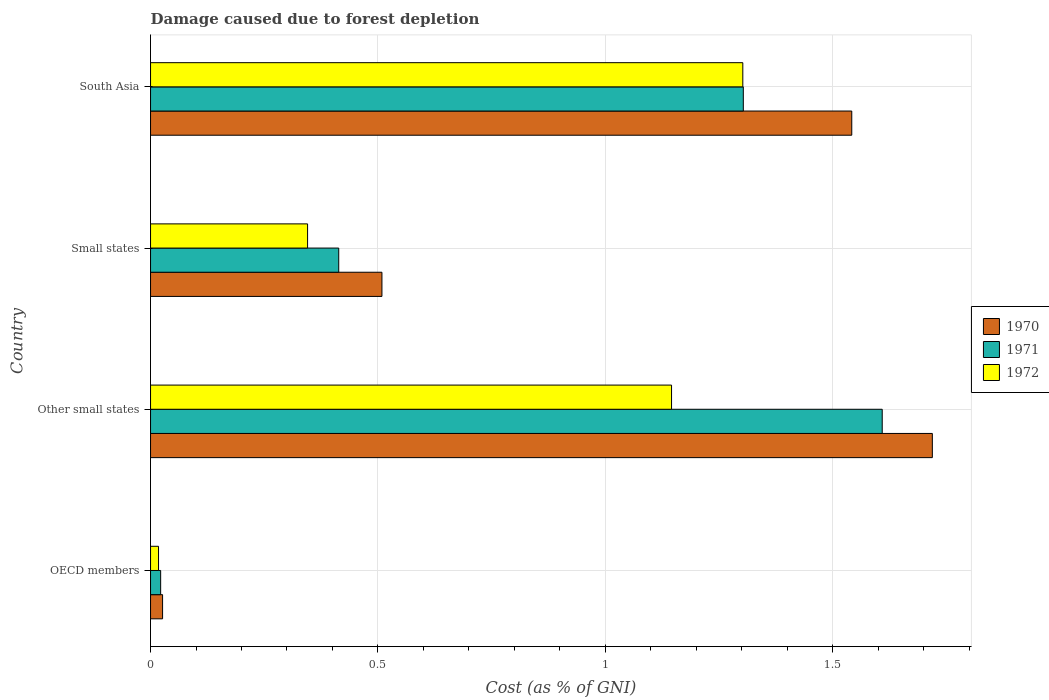How many different coloured bars are there?
Ensure brevity in your answer.  3. Are the number of bars per tick equal to the number of legend labels?
Give a very brief answer. Yes. Are the number of bars on each tick of the Y-axis equal?
Offer a terse response. Yes. How many bars are there on the 2nd tick from the bottom?
Your response must be concise. 3. In how many cases, is the number of bars for a given country not equal to the number of legend labels?
Your answer should be compact. 0. What is the cost of damage caused due to forest depletion in 1970 in Other small states?
Your answer should be very brief. 1.72. Across all countries, what is the maximum cost of damage caused due to forest depletion in 1971?
Provide a short and direct response. 1.61. Across all countries, what is the minimum cost of damage caused due to forest depletion in 1972?
Your response must be concise. 0.02. In which country was the cost of damage caused due to forest depletion in 1971 maximum?
Make the answer very short. Other small states. In which country was the cost of damage caused due to forest depletion in 1972 minimum?
Keep it short and to the point. OECD members. What is the total cost of damage caused due to forest depletion in 1971 in the graph?
Your response must be concise. 3.35. What is the difference between the cost of damage caused due to forest depletion in 1970 in OECD members and that in Small states?
Keep it short and to the point. -0.48. What is the difference between the cost of damage caused due to forest depletion in 1970 in Small states and the cost of damage caused due to forest depletion in 1971 in OECD members?
Offer a terse response. 0.49. What is the average cost of damage caused due to forest depletion in 1972 per country?
Your response must be concise. 0.7. What is the difference between the cost of damage caused due to forest depletion in 1971 and cost of damage caused due to forest depletion in 1970 in OECD members?
Make the answer very short. -0. What is the ratio of the cost of damage caused due to forest depletion in 1971 in Other small states to that in South Asia?
Your answer should be compact. 1.23. What is the difference between the highest and the second highest cost of damage caused due to forest depletion in 1971?
Provide a short and direct response. 0.31. What is the difference between the highest and the lowest cost of damage caused due to forest depletion in 1970?
Offer a very short reply. 1.69. In how many countries, is the cost of damage caused due to forest depletion in 1972 greater than the average cost of damage caused due to forest depletion in 1972 taken over all countries?
Give a very brief answer. 2. What does the 1st bar from the top in Small states represents?
Provide a succinct answer. 1972. Is it the case that in every country, the sum of the cost of damage caused due to forest depletion in 1970 and cost of damage caused due to forest depletion in 1971 is greater than the cost of damage caused due to forest depletion in 1972?
Keep it short and to the point. Yes. How many bars are there?
Give a very brief answer. 12. What is the difference between two consecutive major ticks on the X-axis?
Keep it short and to the point. 0.5. Where does the legend appear in the graph?
Give a very brief answer. Center right. How many legend labels are there?
Offer a terse response. 3. What is the title of the graph?
Offer a very short reply. Damage caused due to forest depletion. What is the label or title of the X-axis?
Your answer should be compact. Cost (as % of GNI). What is the label or title of the Y-axis?
Your response must be concise. Country. What is the Cost (as % of GNI) in 1970 in OECD members?
Your answer should be compact. 0.03. What is the Cost (as % of GNI) of 1971 in OECD members?
Your answer should be very brief. 0.02. What is the Cost (as % of GNI) in 1972 in OECD members?
Your response must be concise. 0.02. What is the Cost (as % of GNI) of 1970 in Other small states?
Provide a succinct answer. 1.72. What is the Cost (as % of GNI) of 1971 in Other small states?
Offer a terse response. 1.61. What is the Cost (as % of GNI) in 1972 in Other small states?
Make the answer very short. 1.15. What is the Cost (as % of GNI) in 1970 in Small states?
Provide a short and direct response. 0.51. What is the Cost (as % of GNI) in 1971 in Small states?
Provide a short and direct response. 0.41. What is the Cost (as % of GNI) in 1972 in Small states?
Your answer should be very brief. 0.35. What is the Cost (as % of GNI) of 1970 in South Asia?
Provide a succinct answer. 1.54. What is the Cost (as % of GNI) in 1971 in South Asia?
Ensure brevity in your answer.  1.3. What is the Cost (as % of GNI) in 1972 in South Asia?
Ensure brevity in your answer.  1.3. Across all countries, what is the maximum Cost (as % of GNI) in 1970?
Make the answer very short. 1.72. Across all countries, what is the maximum Cost (as % of GNI) in 1971?
Give a very brief answer. 1.61. Across all countries, what is the maximum Cost (as % of GNI) in 1972?
Your answer should be compact. 1.3. Across all countries, what is the minimum Cost (as % of GNI) in 1970?
Offer a very short reply. 0.03. Across all countries, what is the minimum Cost (as % of GNI) in 1971?
Ensure brevity in your answer.  0.02. Across all countries, what is the minimum Cost (as % of GNI) of 1972?
Ensure brevity in your answer.  0.02. What is the total Cost (as % of GNI) of 1970 in the graph?
Provide a short and direct response. 3.8. What is the total Cost (as % of GNI) of 1971 in the graph?
Keep it short and to the point. 3.35. What is the total Cost (as % of GNI) of 1972 in the graph?
Your answer should be very brief. 2.81. What is the difference between the Cost (as % of GNI) in 1970 in OECD members and that in Other small states?
Offer a very short reply. -1.69. What is the difference between the Cost (as % of GNI) in 1971 in OECD members and that in Other small states?
Your answer should be very brief. -1.59. What is the difference between the Cost (as % of GNI) of 1972 in OECD members and that in Other small states?
Offer a terse response. -1.13. What is the difference between the Cost (as % of GNI) of 1970 in OECD members and that in Small states?
Provide a succinct answer. -0.48. What is the difference between the Cost (as % of GNI) in 1971 in OECD members and that in Small states?
Ensure brevity in your answer.  -0.39. What is the difference between the Cost (as % of GNI) in 1972 in OECD members and that in Small states?
Your response must be concise. -0.33. What is the difference between the Cost (as % of GNI) of 1970 in OECD members and that in South Asia?
Your answer should be very brief. -1.52. What is the difference between the Cost (as % of GNI) in 1971 in OECD members and that in South Asia?
Ensure brevity in your answer.  -1.28. What is the difference between the Cost (as % of GNI) in 1972 in OECD members and that in South Asia?
Your answer should be very brief. -1.28. What is the difference between the Cost (as % of GNI) of 1970 in Other small states and that in Small states?
Your answer should be very brief. 1.21. What is the difference between the Cost (as % of GNI) of 1971 in Other small states and that in Small states?
Give a very brief answer. 1.2. What is the difference between the Cost (as % of GNI) in 1972 in Other small states and that in Small states?
Provide a short and direct response. 0.8. What is the difference between the Cost (as % of GNI) in 1970 in Other small states and that in South Asia?
Your answer should be compact. 0.18. What is the difference between the Cost (as % of GNI) in 1971 in Other small states and that in South Asia?
Provide a succinct answer. 0.31. What is the difference between the Cost (as % of GNI) of 1972 in Other small states and that in South Asia?
Keep it short and to the point. -0.16. What is the difference between the Cost (as % of GNI) in 1970 in Small states and that in South Asia?
Make the answer very short. -1.03. What is the difference between the Cost (as % of GNI) in 1971 in Small states and that in South Asia?
Your answer should be compact. -0.89. What is the difference between the Cost (as % of GNI) in 1972 in Small states and that in South Asia?
Your response must be concise. -0.96. What is the difference between the Cost (as % of GNI) in 1970 in OECD members and the Cost (as % of GNI) in 1971 in Other small states?
Your answer should be very brief. -1.58. What is the difference between the Cost (as % of GNI) in 1970 in OECD members and the Cost (as % of GNI) in 1972 in Other small states?
Keep it short and to the point. -1.12. What is the difference between the Cost (as % of GNI) of 1971 in OECD members and the Cost (as % of GNI) of 1972 in Other small states?
Your response must be concise. -1.12. What is the difference between the Cost (as % of GNI) of 1970 in OECD members and the Cost (as % of GNI) of 1971 in Small states?
Provide a short and direct response. -0.39. What is the difference between the Cost (as % of GNI) in 1970 in OECD members and the Cost (as % of GNI) in 1972 in Small states?
Your answer should be compact. -0.32. What is the difference between the Cost (as % of GNI) in 1971 in OECD members and the Cost (as % of GNI) in 1972 in Small states?
Keep it short and to the point. -0.32. What is the difference between the Cost (as % of GNI) in 1970 in OECD members and the Cost (as % of GNI) in 1971 in South Asia?
Offer a very short reply. -1.28. What is the difference between the Cost (as % of GNI) in 1970 in OECD members and the Cost (as % of GNI) in 1972 in South Asia?
Give a very brief answer. -1.28. What is the difference between the Cost (as % of GNI) in 1971 in OECD members and the Cost (as % of GNI) in 1972 in South Asia?
Your response must be concise. -1.28. What is the difference between the Cost (as % of GNI) of 1970 in Other small states and the Cost (as % of GNI) of 1971 in Small states?
Keep it short and to the point. 1.31. What is the difference between the Cost (as % of GNI) in 1970 in Other small states and the Cost (as % of GNI) in 1972 in Small states?
Offer a terse response. 1.37. What is the difference between the Cost (as % of GNI) in 1971 in Other small states and the Cost (as % of GNI) in 1972 in Small states?
Provide a succinct answer. 1.26. What is the difference between the Cost (as % of GNI) of 1970 in Other small states and the Cost (as % of GNI) of 1971 in South Asia?
Ensure brevity in your answer.  0.42. What is the difference between the Cost (as % of GNI) in 1970 in Other small states and the Cost (as % of GNI) in 1972 in South Asia?
Offer a terse response. 0.42. What is the difference between the Cost (as % of GNI) of 1971 in Other small states and the Cost (as % of GNI) of 1972 in South Asia?
Offer a very short reply. 0.31. What is the difference between the Cost (as % of GNI) of 1970 in Small states and the Cost (as % of GNI) of 1971 in South Asia?
Your answer should be compact. -0.79. What is the difference between the Cost (as % of GNI) of 1970 in Small states and the Cost (as % of GNI) of 1972 in South Asia?
Offer a terse response. -0.79. What is the difference between the Cost (as % of GNI) of 1971 in Small states and the Cost (as % of GNI) of 1972 in South Asia?
Make the answer very short. -0.89. What is the average Cost (as % of GNI) of 1970 per country?
Offer a terse response. 0.95. What is the average Cost (as % of GNI) of 1971 per country?
Your answer should be very brief. 0.84. What is the average Cost (as % of GNI) of 1972 per country?
Give a very brief answer. 0.7. What is the difference between the Cost (as % of GNI) in 1970 and Cost (as % of GNI) in 1971 in OECD members?
Offer a very short reply. 0. What is the difference between the Cost (as % of GNI) in 1970 and Cost (as % of GNI) in 1972 in OECD members?
Offer a very short reply. 0.01. What is the difference between the Cost (as % of GNI) in 1971 and Cost (as % of GNI) in 1972 in OECD members?
Give a very brief answer. 0. What is the difference between the Cost (as % of GNI) of 1970 and Cost (as % of GNI) of 1971 in Other small states?
Provide a succinct answer. 0.11. What is the difference between the Cost (as % of GNI) of 1970 and Cost (as % of GNI) of 1972 in Other small states?
Give a very brief answer. 0.57. What is the difference between the Cost (as % of GNI) in 1971 and Cost (as % of GNI) in 1972 in Other small states?
Give a very brief answer. 0.46. What is the difference between the Cost (as % of GNI) of 1970 and Cost (as % of GNI) of 1971 in Small states?
Offer a very short reply. 0.1. What is the difference between the Cost (as % of GNI) in 1970 and Cost (as % of GNI) in 1972 in Small states?
Give a very brief answer. 0.16. What is the difference between the Cost (as % of GNI) of 1971 and Cost (as % of GNI) of 1972 in Small states?
Your answer should be compact. 0.07. What is the difference between the Cost (as % of GNI) of 1970 and Cost (as % of GNI) of 1971 in South Asia?
Make the answer very short. 0.24. What is the difference between the Cost (as % of GNI) of 1970 and Cost (as % of GNI) of 1972 in South Asia?
Your answer should be compact. 0.24. What is the difference between the Cost (as % of GNI) in 1971 and Cost (as % of GNI) in 1972 in South Asia?
Your answer should be very brief. 0. What is the ratio of the Cost (as % of GNI) of 1970 in OECD members to that in Other small states?
Your answer should be very brief. 0.02. What is the ratio of the Cost (as % of GNI) of 1971 in OECD members to that in Other small states?
Your answer should be very brief. 0.01. What is the ratio of the Cost (as % of GNI) of 1972 in OECD members to that in Other small states?
Your answer should be very brief. 0.02. What is the ratio of the Cost (as % of GNI) of 1970 in OECD members to that in Small states?
Provide a succinct answer. 0.05. What is the ratio of the Cost (as % of GNI) in 1971 in OECD members to that in Small states?
Provide a succinct answer. 0.05. What is the ratio of the Cost (as % of GNI) of 1972 in OECD members to that in Small states?
Provide a succinct answer. 0.05. What is the ratio of the Cost (as % of GNI) in 1970 in OECD members to that in South Asia?
Make the answer very short. 0.02. What is the ratio of the Cost (as % of GNI) in 1971 in OECD members to that in South Asia?
Offer a terse response. 0.02. What is the ratio of the Cost (as % of GNI) in 1972 in OECD members to that in South Asia?
Your answer should be compact. 0.01. What is the ratio of the Cost (as % of GNI) of 1970 in Other small states to that in Small states?
Ensure brevity in your answer.  3.38. What is the ratio of the Cost (as % of GNI) in 1971 in Other small states to that in Small states?
Your answer should be very brief. 3.89. What is the ratio of the Cost (as % of GNI) in 1972 in Other small states to that in Small states?
Provide a short and direct response. 3.32. What is the ratio of the Cost (as % of GNI) of 1970 in Other small states to that in South Asia?
Offer a very short reply. 1.11. What is the ratio of the Cost (as % of GNI) in 1971 in Other small states to that in South Asia?
Provide a succinct answer. 1.23. What is the ratio of the Cost (as % of GNI) in 1972 in Other small states to that in South Asia?
Give a very brief answer. 0.88. What is the ratio of the Cost (as % of GNI) of 1970 in Small states to that in South Asia?
Ensure brevity in your answer.  0.33. What is the ratio of the Cost (as % of GNI) of 1971 in Small states to that in South Asia?
Keep it short and to the point. 0.32. What is the ratio of the Cost (as % of GNI) in 1972 in Small states to that in South Asia?
Provide a short and direct response. 0.27. What is the difference between the highest and the second highest Cost (as % of GNI) of 1970?
Your response must be concise. 0.18. What is the difference between the highest and the second highest Cost (as % of GNI) in 1971?
Make the answer very short. 0.31. What is the difference between the highest and the second highest Cost (as % of GNI) in 1972?
Your answer should be very brief. 0.16. What is the difference between the highest and the lowest Cost (as % of GNI) of 1970?
Your response must be concise. 1.69. What is the difference between the highest and the lowest Cost (as % of GNI) in 1971?
Provide a short and direct response. 1.59. What is the difference between the highest and the lowest Cost (as % of GNI) in 1972?
Your answer should be very brief. 1.28. 